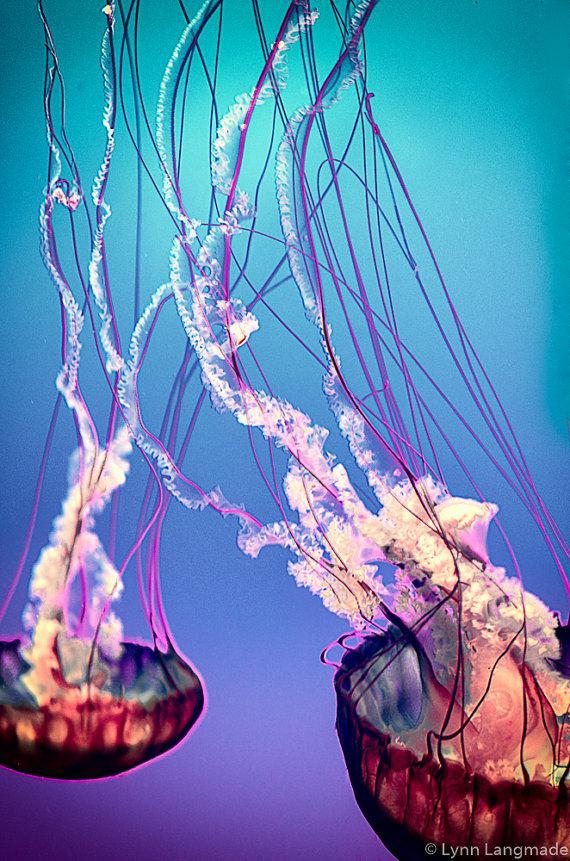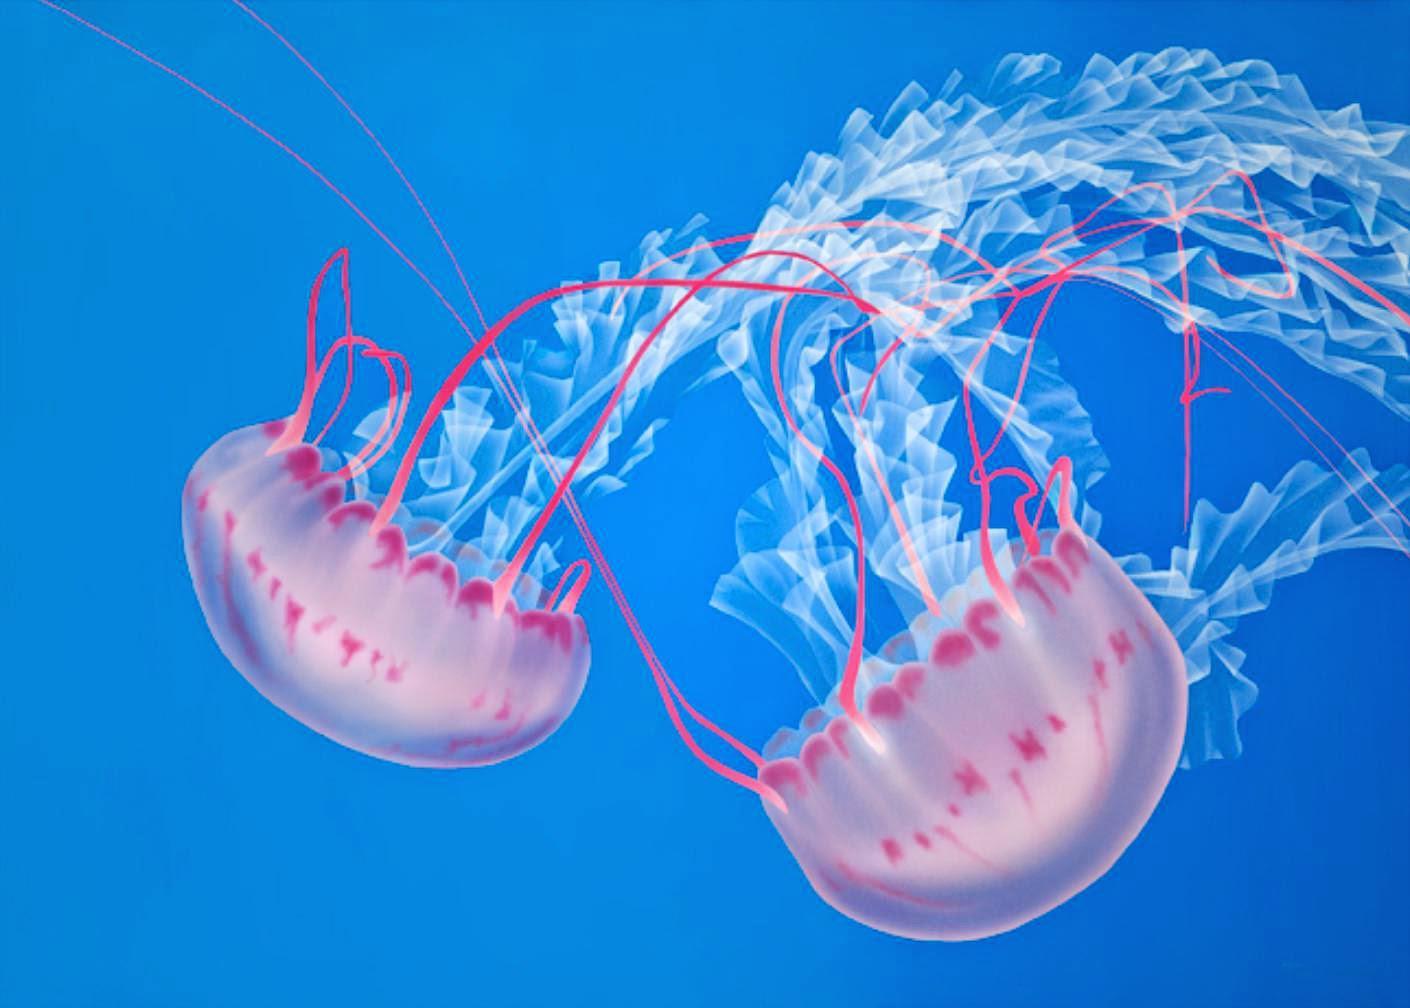The first image is the image on the left, the second image is the image on the right. Evaluate the accuracy of this statement regarding the images: "There are pale pink jellyfish with a clear blue background". Is it true? Answer yes or no. Yes. 